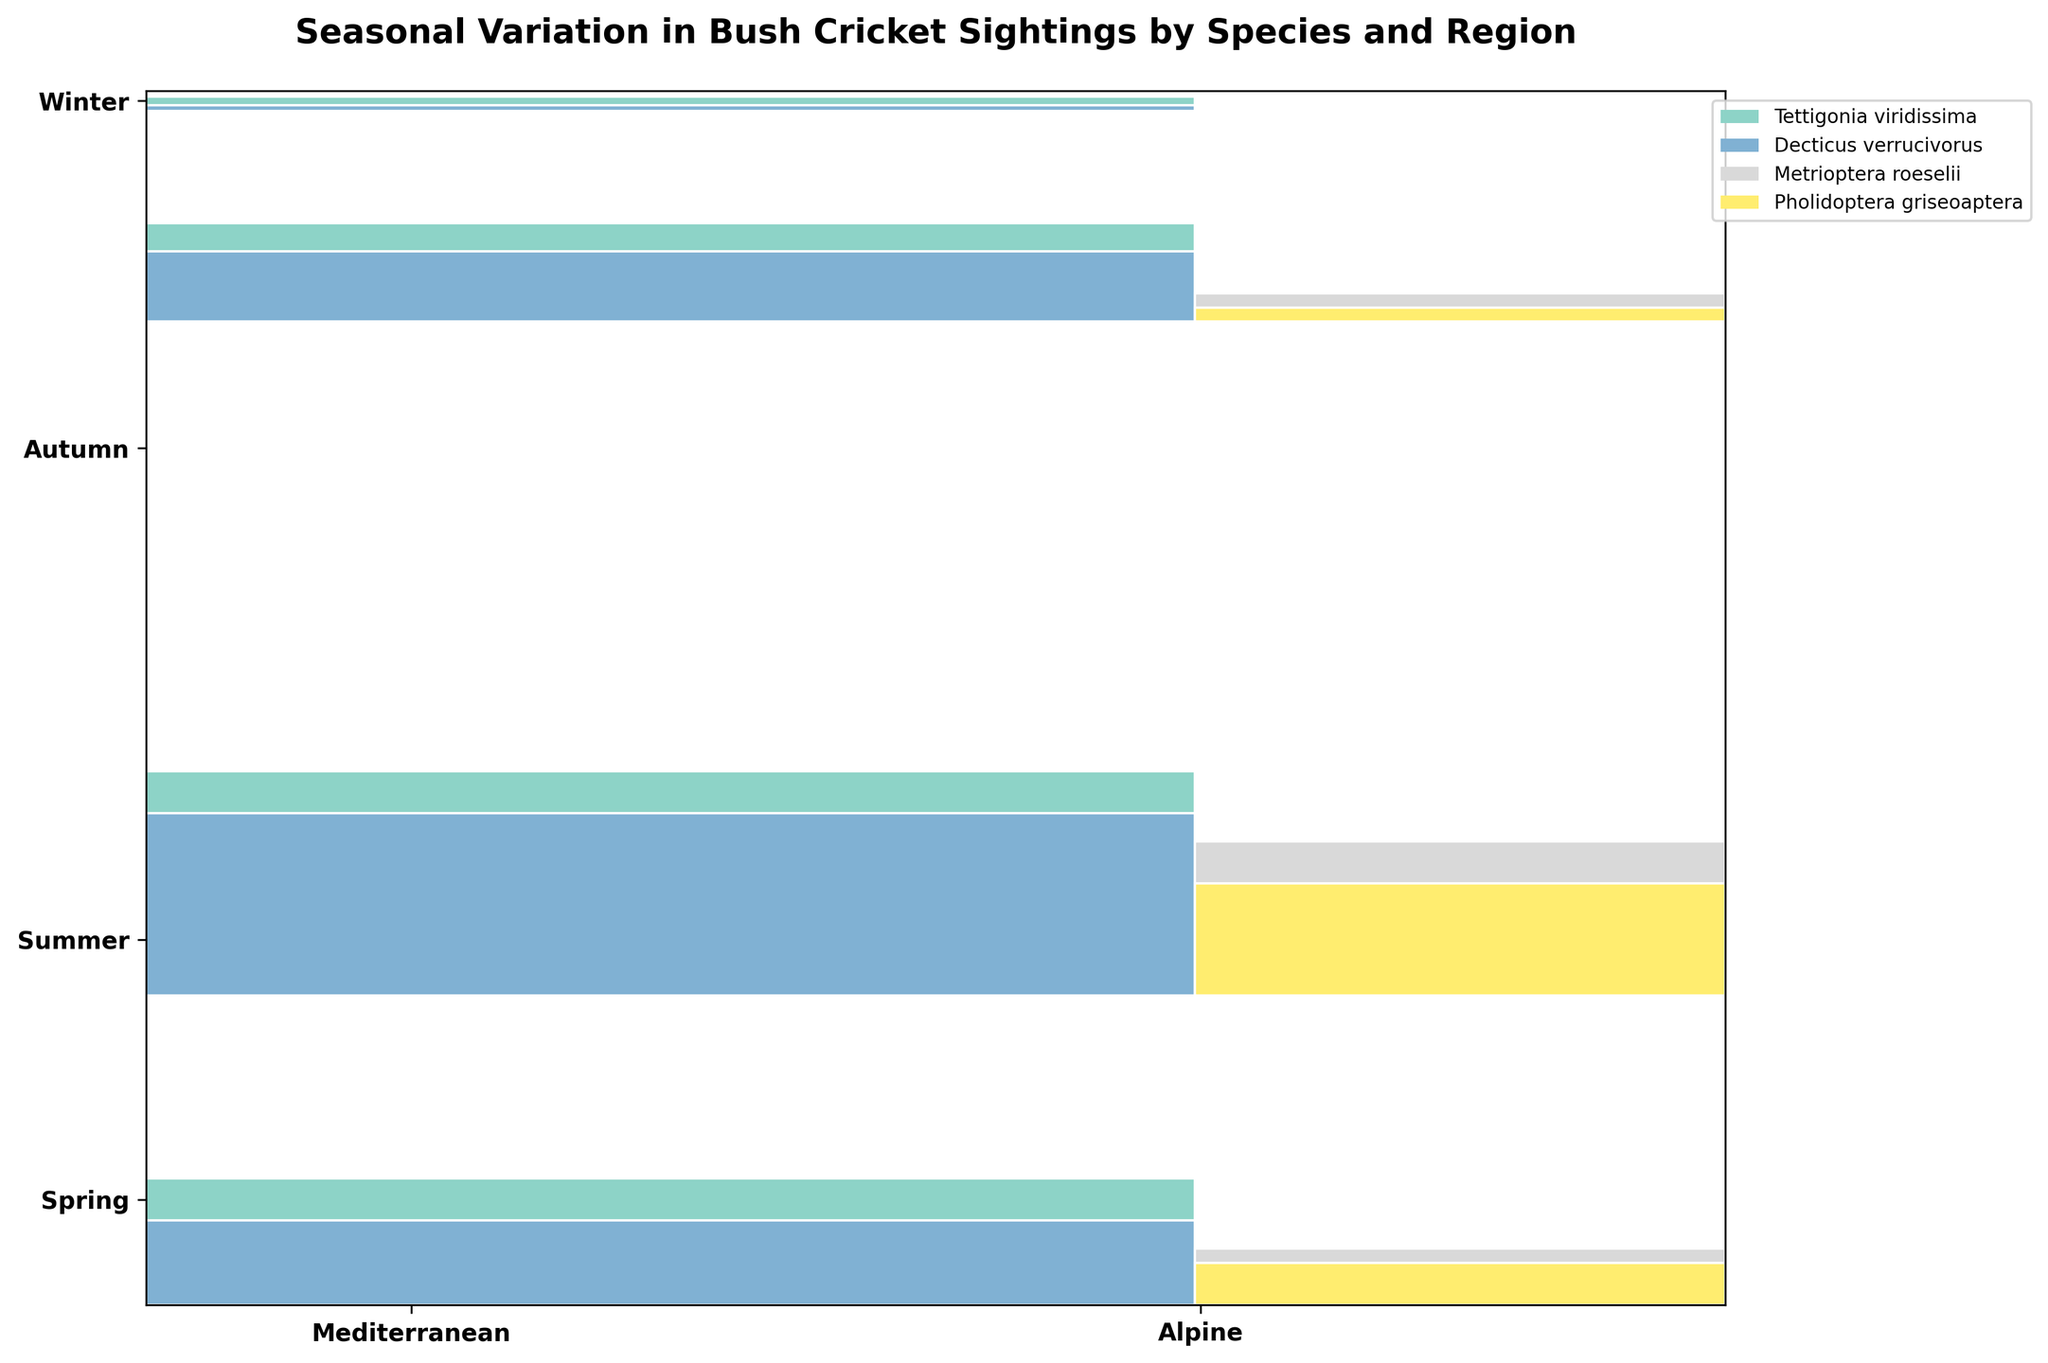What is the title of the mosaic plot? The title is displayed at the top of the plot in bold text.
Answer: Seasonal Variation in Bush Cricket Sightings by Species and Region Which season has the highest proportion of bush cricket sightings? The height of each season's section corresponds to its proportion of total sightings. The tallest section represents Summer.
Answer: Summer During which season and in which region are Tettigonia viridissima sightings the highest? Tettigonia viridissima is represented by a specific color. The height of the colored block within each season and region section shows the number of sightings. The highest is in the Mediterranean region during Summer.
Answer: Summer, Mediterranean How many distinct species of bush crickets are recorded in the figure? Each species is represented by a different color in the legend. There are four distinct colors.
Answer: Four In which season and region are no bush cricket sightings recorded? Look for an empty section in the mosaic plot. The Winter section in the Alpine region has no sightings (hence, no colored blocks).
Answer: Winter, Alpine Compare the sightings of Metrioptera roeselii in Spring and Autumn in the Alpine region. Which has more sightings? Find the sections for Metrioptera roeselii in Spring and Autumn within the Alpine region. Compare the heights of the corresponding colored blocks. Spring has a higher block than Autumn.
Answer: Spring Which species has the least variation in sightings across the seasons in the Mediterranean region? Look for the series of colored blocks in the Mediterranean region and observe the height consistency. Decticus verrucivorus has relatively consistent block heights.
Answer: Decticus verrucivorus What is the total proportion of sightings for all species in the Winter season? Sum the heights of all blocks in the Winter section. The sum represents the winter's proportion.
Answer: Approximately 0.02 (2%) Is there any species not sighted at all in Winter? Look for the sections with no block (height = 0) in Winter. Metrioptera roeselii and Pholidoptera griseoaptera have no blocks in Winter.
Answer: Yes, two species 